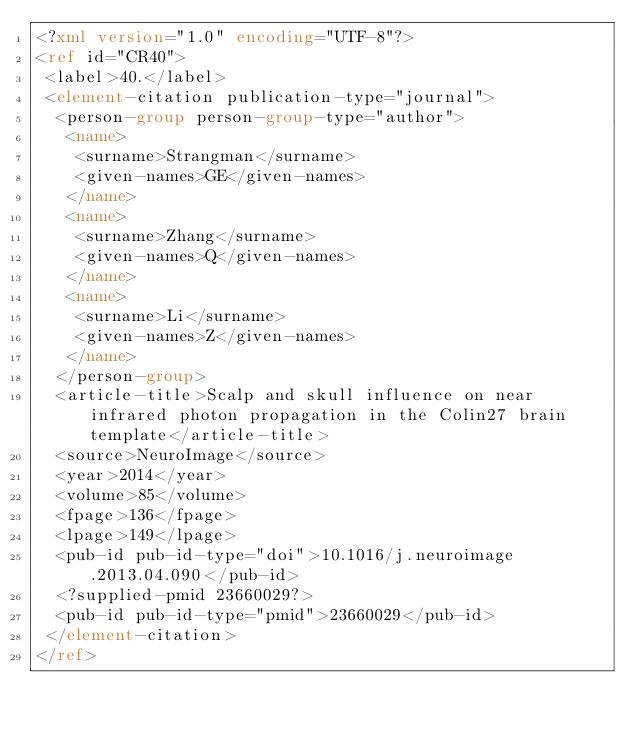Convert code to text. <code><loc_0><loc_0><loc_500><loc_500><_XML_><?xml version="1.0" encoding="UTF-8"?>
<ref id="CR40">
 <label>40.</label>
 <element-citation publication-type="journal">
  <person-group person-group-type="author">
   <name>
    <surname>Strangman</surname>
    <given-names>GE</given-names>
   </name>
   <name>
    <surname>Zhang</surname>
    <given-names>Q</given-names>
   </name>
   <name>
    <surname>Li</surname>
    <given-names>Z</given-names>
   </name>
  </person-group>
  <article-title>Scalp and skull influence on near infrared photon propagation in the Colin27 brain template</article-title>
  <source>NeuroImage</source>
  <year>2014</year>
  <volume>85</volume>
  <fpage>136</fpage>
  <lpage>149</lpage>
  <pub-id pub-id-type="doi">10.1016/j.neuroimage.2013.04.090</pub-id>
  <?supplied-pmid 23660029?>
  <pub-id pub-id-type="pmid">23660029</pub-id>
 </element-citation>
</ref>
</code> 